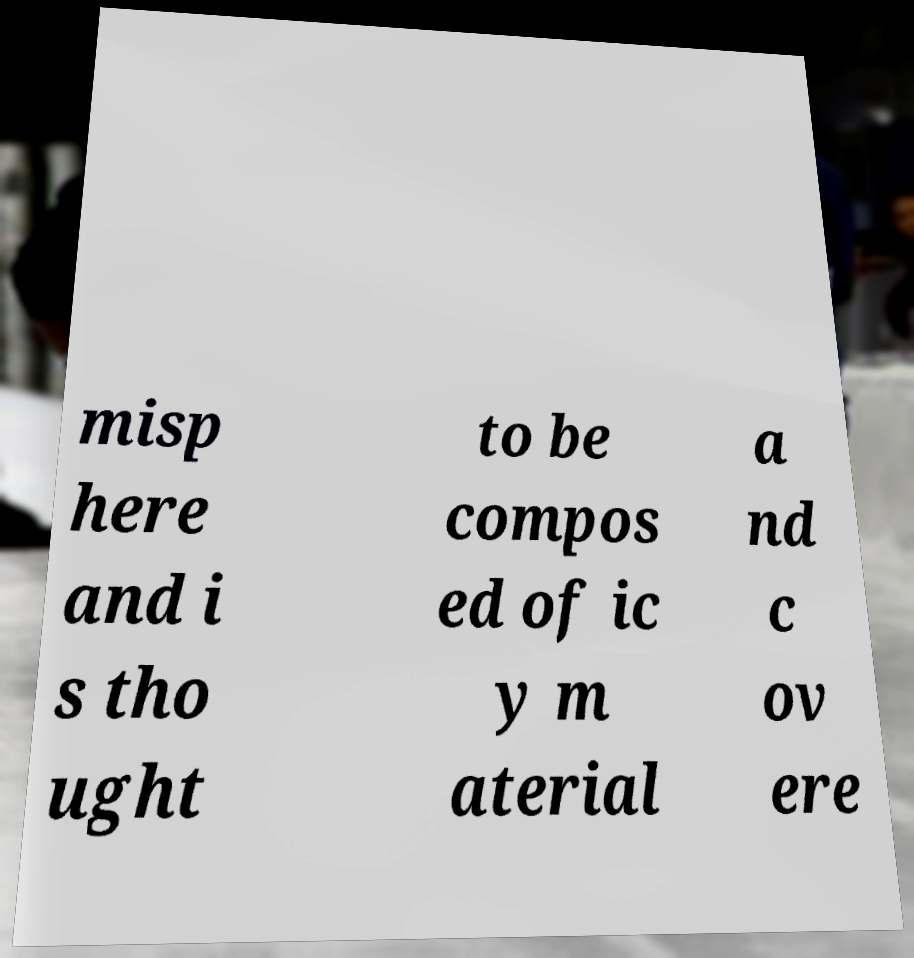There's text embedded in this image that I need extracted. Can you transcribe it verbatim? misp here and i s tho ught to be compos ed of ic y m aterial a nd c ov ere 